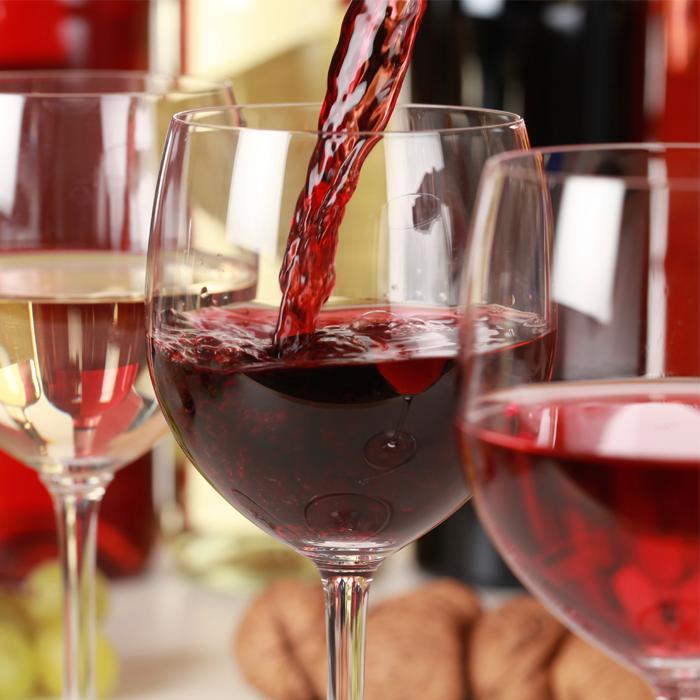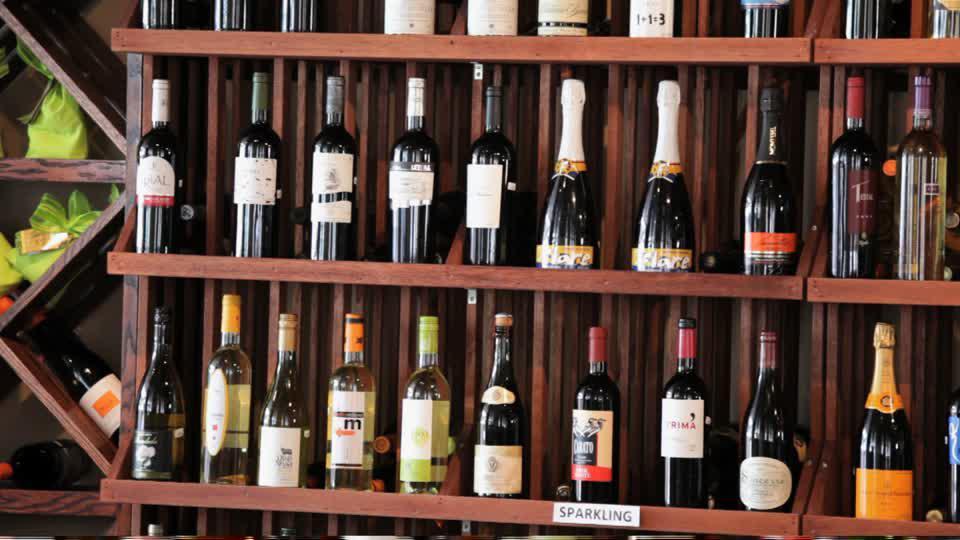The first image is the image on the left, the second image is the image on the right. Assess this claim about the two images: "At least one image shows wine bottles stored in a rack.". Correct or not? Answer yes or no. Yes. 